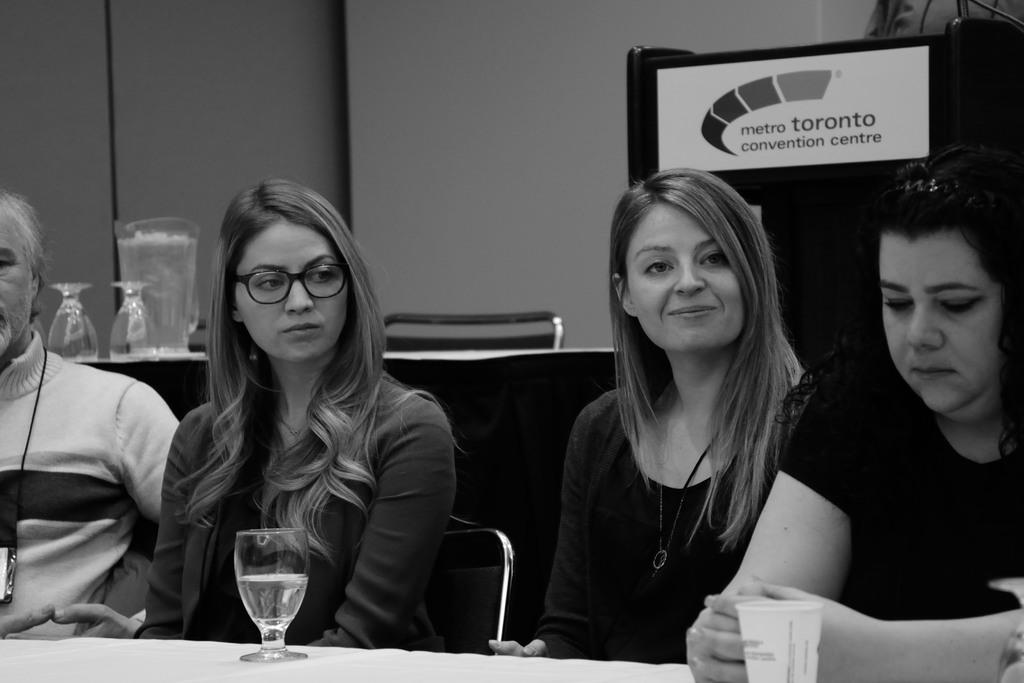What is the color of the wall in the image? The wall in the image is white. What objects can be seen on the table in the image? There is a glass on the table in the image. How many people are sitting on chairs in the image? There are four people sitting on chairs in the image. What is the purpose of the chairs in the image? The chairs are likely for the people to sit on during a gathering or event. What is the relationship between the glasses and the table in the image? The glasses are placed on the table, suggesting they are being used or are available for use. How many dimes are placed on the shelf in the image? There is no shelf or dimes present in the image. What type of writing instrument is being used by the people sitting on the chairs in the image? There is no writing instrument visible in the image, and the people are not shown using any. 